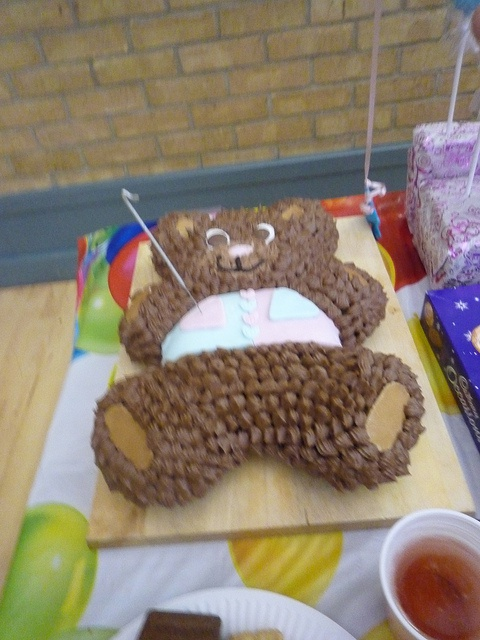Describe the objects in this image and their specific colors. I can see cake in gray and maroon tones, teddy bear in gray and maroon tones, dining table in gray and tan tones, cup in gray, maroon, brown, darkgray, and lavender tones, and bowl in gray, maroon, brown, darkgray, and lavender tones in this image. 